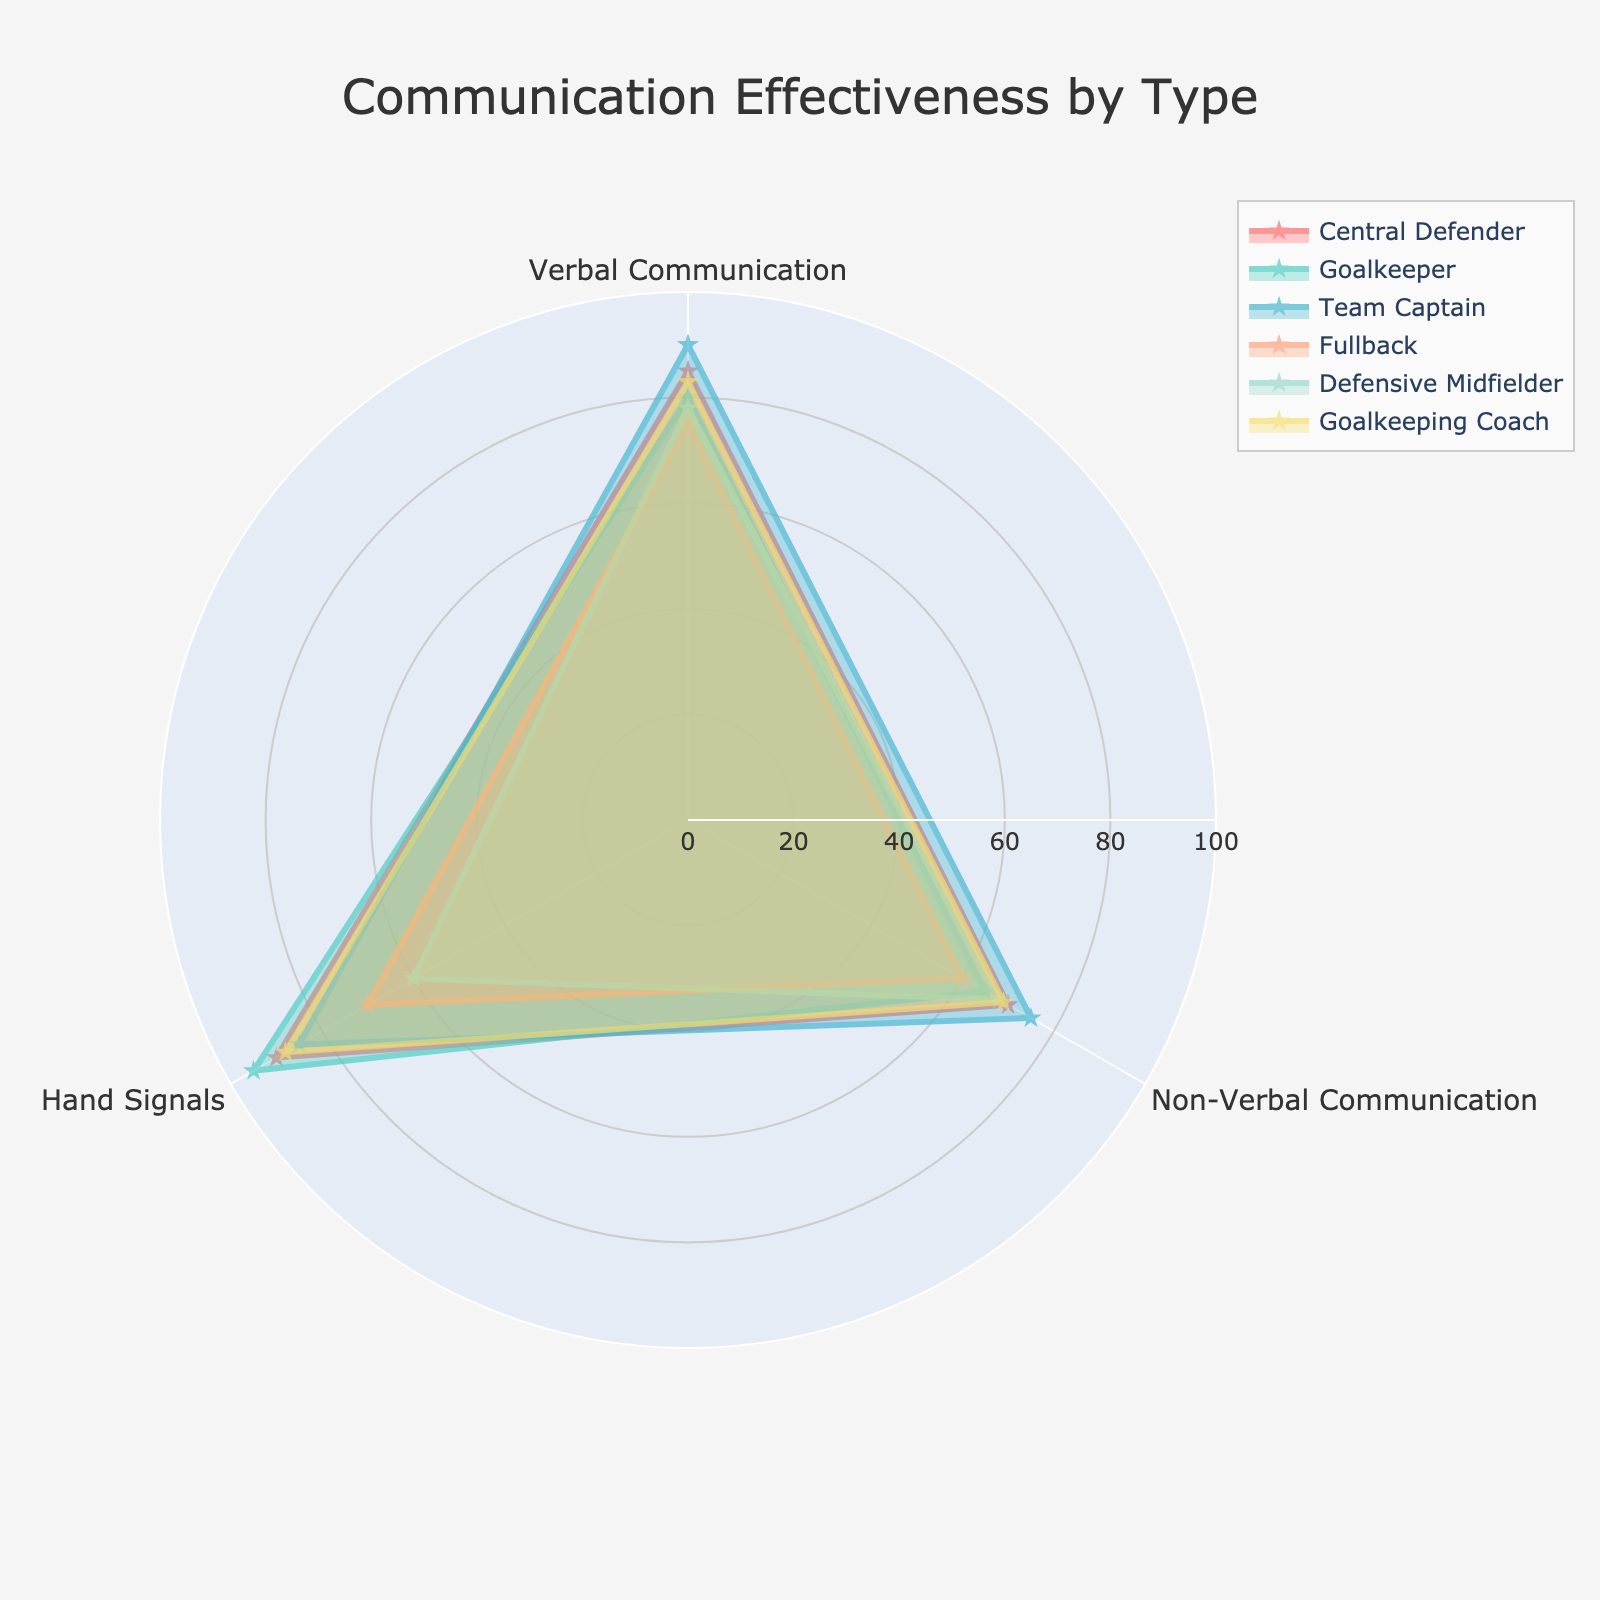What is the title of the figure? Look at the top of the radar chart where the title is prominently displayed. It usually provides a brief description of the purpose of the plot.
Answer: Communication Effectiveness by Type Which entity has the highest Hand Signals effectiveness? Inspect the radar chart and identify which entity's data extends furthest along the Hand Signals axis.
Answer: Goalkeeper What is the difference in Verbal Communication scores between the Central Defender and the Fullback? Find the Verbal Communication scores for both entities on the chart, then subtract the Fullback's score from the Central Defender's score. The Central Defender has a score of 85, and the Fullback has a score of 75, so the difference is 85 - 75.
Answer: 10 Which entity has the lowest Non-Verbal Communication score? Look along the Non-Verbal Communication axis and identify which entity's data point is closest to the center of the radar chart.
Answer: Fullback What is the average Hand Signals effectiveness score for the Central Defender, Team Captain, and Goalkeeper? Locate the Hand Signals scores for the Central Defender (90), Team Captain (85), and Goalkeeper (95). Sum these values and divide by the number of entities: (90 + 85 + 95) / 3.
Answer: 90 Which two entities have the most similar overall communication effectiveness profiles? Examine the overall shape and proximity of the areas covered by each entity on the radar chart to determine which entities have the most similar scores across all communication effective types.
Answer: Central Defender and Goalkeeping Coach How much higher is the Goalkeeping Coach's Non-Verbal Communication score compared to the Goalkeeper's? Check the Non-Verbal Communication scores for both the Goalkeeping Coach (69) and the Goalkeeper (65), then subtract the Goalkeeper's score from the Goalkeeping Coach's score: 69 - 65.
Answer: 4 Which communication type does the Defensive Midfielder score the lowest in? For the Defensive Midfielder, compare the lengths of the plot points along each type of communication axis and identify the shortest one.
Answer: Hand Signals What is the total Verbal Communication score of the Central Defender, Goalkeeper, and Goalkeeping Coach combined? Find the Verbal Communication scores for each (Central Defender: 85, Goalkeeper: 80, Goalkeeping Coach: 83), then sum these values: 85 + 80 + 83.
Answer: 248 